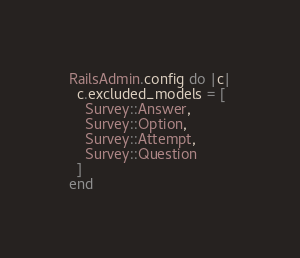<code> <loc_0><loc_0><loc_500><loc_500><_Ruby_>RailsAdmin.config do |c|
  c.excluded_models = [
    Survey::Answer,
    Survey::Option,
    Survey::Attempt,
    Survey::Question
  ]
end</code> 